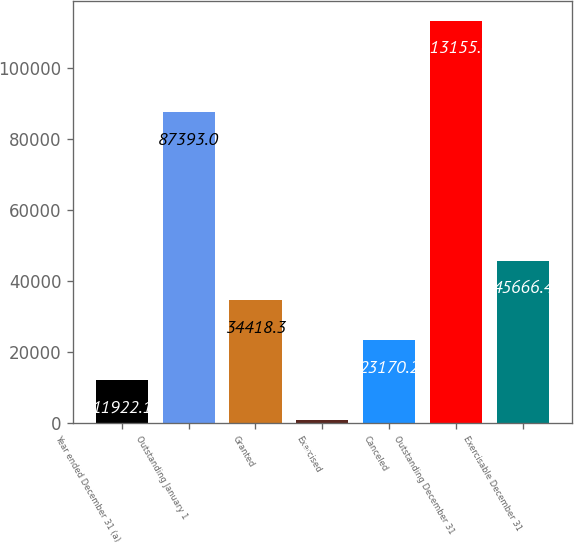Convert chart to OTSL. <chart><loc_0><loc_0><loc_500><loc_500><bar_chart><fcel>Year ended December 31 (a)<fcel>Outstanding January 1<fcel>Granted<fcel>Exercised<fcel>Canceled<fcel>Outstanding December 31<fcel>Exercisable December 31<nl><fcel>11922.1<fcel>87393<fcel>34418.3<fcel>674<fcel>23170.2<fcel>113155<fcel>45666.4<nl></chart> 